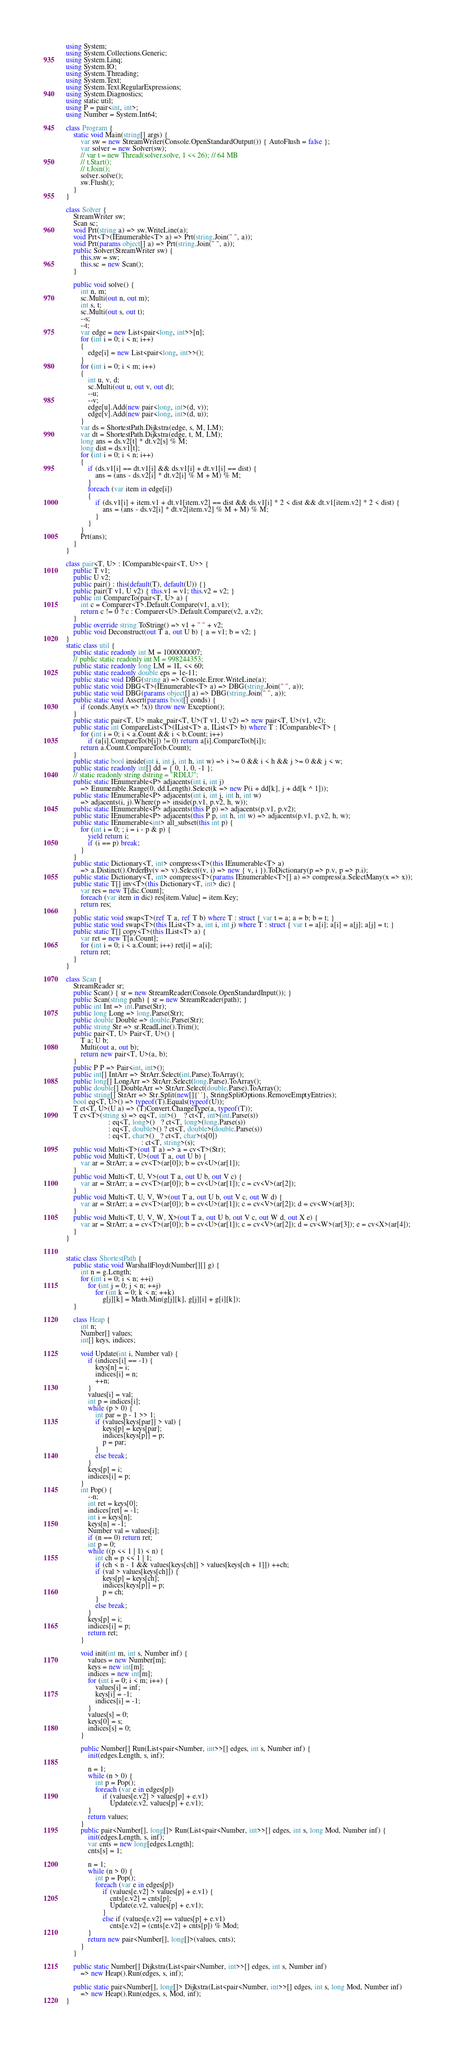<code> <loc_0><loc_0><loc_500><loc_500><_C#_>using System;
using System.Collections.Generic;
using System.Linq;
using System.IO;
using System.Threading;
using System.Text;
using System.Text.RegularExpressions;
using System.Diagnostics;
using static util;
using P = pair<int, int>;
using Number = System.Int64;

class Program {
    static void Main(string[] args) {
        var sw = new StreamWriter(Console.OpenStandardOutput()) { AutoFlush = false };
        var solver = new Solver(sw);
        // var t = new Thread(solver.solve, 1 << 26); // 64 MB
        // t.Start();
        // t.Join();
        solver.solve();
        sw.Flush();
    }
}

class Solver {
    StreamWriter sw;
    Scan sc;
    void Prt(string a) => sw.WriteLine(a);
    void Prt<T>(IEnumerable<T> a) => Prt(string.Join(" ", a));
    void Prt(params object[] a) => Prt(string.Join(" ", a));
    public Solver(StreamWriter sw) {
        this.sw = sw;
        this.sc = new Scan();
    }

    public void solve() {
        int n, m;
        sc.Multi(out n, out m);
        int s, t;
        sc.Multi(out s, out t);
        --s;
        --t;
        var edge = new List<pair<long, int>>[n];
        for (int i = 0; i < n; i++)
        {
            edge[i] = new List<pair<long, int>>();
        }
        for (int i = 0; i < m; i++)
        {
            int u, v, d;
            sc.Multi(out u, out v, out d);
            --u;
            --v;
            edge[u].Add(new pair<long, int>(d, v));
            edge[v].Add(new pair<long, int>(d, u));
        }
        var ds = ShortestPath.Dijkstra(edge, s, M, LM);
        var dt = ShortestPath.Dijkstra(edge, t, M, LM);
        long ans = ds.v2[t] * dt.v2[s] % M;
        long dist = ds.v1[t];
        for (int i = 0; i < n; i++)
        {
            if (ds.v1[i] == dt.v1[i] && ds.v1[i] + dt.v1[i] == dist) {
                ans = (ans - ds.v2[i] * dt.v2[i] % M + M) % M;
            }
            foreach (var item in edge[i])
            {
                if (ds.v1[i] + item.v1 + dt.v1[item.v2] == dist && ds.v1[i] * 2 < dist && dt.v1[item.v2] * 2 < dist) {
                    ans = (ans - ds.v2[i] * dt.v2[item.v2] % M + M) % M;
                }
            }
        }
        Prt(ans);
    }
}

class pair<T, U> : IComparable<pair<T, U>> {
    public T v1;
    public U v2;
    public pair() : this(default(T), default(U)) {}
    public pair(T v1, U v2) { this.v1 = v1; this.v2 = v2; }
    public int CompareTo(pair<T, U> a) {
        int c = Comparer<T>.Default.Compare(v1, a.v1);
        return c != 0 ? c : Comparer<U>.Default.Compare(v2, a.v2);
    }
    public override string ToString() => v1 + " " + v2;
    public void Deconstruct(out T a, out U b) { a = v1; b = v2; }
}
static class util {
    public static readonly int M = 1000000007;
    // public static readonly int M = 998244353;
    public static readonly long LM = 1L << 60;
    public static readonly double eps = 1e-11;
    public static void DBG(string a) => Console.Error.WriteLine(a);
    public static void DBG<T>(IEnumerable<T> a) => DBG(string.Join(" ", a));
    public static void DBG(params object[] a) => DBG(string.Join(" ", a));
    public static void Assert(params bool[] conds) {
        if (conds.Any(x => !x)) throw new Exception();
    }
    public static pair<T, U> make_pair<T, U>(T v1, U v2) => new pair<T, U>(v1, v2);
    public static int CompareList<T>(IList<T> a, IList<T> b) where T : IComparable<T> {
        for (int i = 0; i < a.Count && i < b.Count; i++)
            if (a[i].CompareTo(b[i]) != 0) return a[i].CompareTo(b[i]);
        return a.Count.CompareTo(b.Count);
    }
    public static bool inside(int i, int j, int h, int w) => i >= 0 && i < h && j >= 0 && j < w;
    public static readonly int[] dd = { 0, 1, 0, -1 };
    // static readonly string dstring = "RDLU";
    public static IEnumerable<P> adjacents(int i, int j)
        => Enumerable.Range(0, dd.Length).Select(k => new P(i + dd[k], j + dd[k ^ 1]));
    public static IEnumerable<P> adjacents(int i, int j, int h, int w)
        => adjacents(i, j).Where(p => inside(p.v1, p.v2, h, w));
    public static IEnumerable<P> adjacents(this P p) => adjacents(p.v1, p.v2);
    public static IEnumerable<P> adjacents(this P p, int h, int w) => adjacents(p.v1, p.v2, h, w);
    public static IEnumerable<int> all_subset(this int p) {
        for (int i = 0; ; i = i - p & p) {
            yield return i;
            if (i == p) break;
        }
    }
    public static Dictionary<T, int> compress<T>(this IEnumerable<T> a)
        => a.Distinct().OrderBy(v => v).Select((v, i) => new { v, i }).ToDictionary(p => p.v, p => p.i);
    public static Dictionary<T, int> compress<T>(params IEnumerable<T>[] a) => compress(a.SelectMany(x => x));
    public static T[] inv<T>(this Dictionary<T, int> dic) {
        var res = new T[dic.Count];
        foreach (var item in dic) res[item.Value] = item.Key;
        return res;
    }
    public static void swap<T>(ref T a, ref T b) where T : struct { var t = a; a = b; b = t; }
    public static void swap<T>(this IList<T> a, int i, int j) where T : struct { var t = a[i]; a[i] = a[j]; a[j] = t; }
    public static T[] copy<T>(this IList<T> a) {
        var ret = new T[a.Count];
        for (int i = 0; i < a.Count; i++) ret[i] = a[i];
        return ret;
    }
}

class Scan {
    StreamReader sr;
    public Scan() { sr = new StreamReader(Console.OpenStandardInput()); }
    public Scan(string path) { sr = new StreamReader(path); }
    public int Int => int.Parse(Str);
    public long Long => long.Parse(Str);
    public double Double => double.Parse(Str);
    public string Str => sr.ReadLine().Trim();
    public pair<T, U> Pair<T, U>() {
        T a; U b;
        Multi(out a, out b);
        return new pair<T, U>(a, b);
    }
    public P P => Pair<int, int>();
    public int[] IntArr => StrArr.Select(int.Parse).ToArray();
    public long[] LongArr => StrArr.Select(long.Parse).ToArray();
    public double[] DoubleArr => StrArr.Select(double.Parse).ToArray();
    public string[] StrArr => Str.Split(new[]{' '}, StringSplitOptions.RemoveEmptyEntries);
    bool eq<T, U>() => typeof(T).Equals(typeof(U));
    T ct<T, U>(U a) => (T)Convert.ChangeType(a, typeof(T));
    T cv<T>(string s) => eq<T, int>()    ? ct<T, int>(int.Parse(s))
                       : eq<T, long>()   ? ct<T, long>(long.Parse(s))
                       : eq<T, double>() ? ct<T, double>(double.Parse(s))
                       : eq<T, char>()   ? ct<T, char>(s[0])
                                         : ct<T, string>(s);
    public void Multi<T>(out T a) => a = cv<T>(Str);
    public void Multi<T, U>(out T a, out U b) {
        var ar = StrArr; a = cv<T>(ar[0]); b = cv<U>(ar[1]);
    }
    public void Multi<T, U, V>(out T a, out U b, out V c) {
        var ar = StrArr; a = cv<T>(ar[0]); b = cv<U>(ar[1]); c = cv<V>(ar[2]);
    }
    public void Multi<T, U, V, W>(out T a, out U b, out V c, out W d) {
        var ar = StrArr; a = cv<T>(ar[0]); b = cv<U>(ar[1]); c = cv<V>(ar[2]); d = cv<W>(ar[3]);
    }
    public void Multi<T, U, V, W, X>(out T a, out U b, out V c, out W d, out X e) {
        var ar = StrArr; a = cv<T>(ar[0]); b = cv<U>(ar[1]); c = cv<V>(ar[2]); d = cv<W>(ar[3]); e = cv<X>(ar[4]);
    }
}


static class ShortestPath {
    public static void WarshallFloyd(Number[][] g) {
        int n = g.Length;
        for (int i = 0; i < n; ++i)
            for (int j = 0; j < n; ++j)
                for (int k = 0; k < n; ++k)
                    g[j][k] = Math.Min(g[j][k], g[j][i] + g[i][k]);
    }

    class Heap {
        int n;
        Number[] values;
        int[] keys, indices;

        void Update(int i, Number val) {
            if (indices[i] == -1) {
                keys[n] = i;
                indices[i] = n;
                ++n;
            }
            values[i] = val;
            int p = indices[i];
            while (p > 0) {
                int par = p - 1 >> 1;
                if (values[keys[par]] > val) {
                    keys[p] = keys[par];
                    indices[keys[p]] = p;
                    p = par;
                }
                else break;
            }
            keys[p] = i;
            indices[i] = p;
        }
        int Pop() {
            --n;
            int ret = keys[0];
            indices[ret] = -1;
            int i = keys[n];
            keys[n] = -1;
            Number val = values[i];
            if (n == 0) return ret;
            int p = 0;
            while ((p << 1 | 1) < n) {
                int ch = p << 1 | 1;
                if (ch < n - 1 && values[keys[ch]] > values[keys[ch + 1]]) ++ch;
                if (val > values[keys[ch]]) {
                    keys[p] = keys[ch];
                    indices[keys[p]] = p;
                    p = ch;
                }
                else break;
            }
            keys[p] = i;
            indices[i] = p;
            return ret;
        }

        void init(int m, int s, Number inf) {
            values = new Number[m];
            keys = new int[m];
            indices = new int[m];
            for (int i = 0; i < m; i++) {
                values[i] = inf;
                keys[i] = -1;
                indices[i] = -1;
            }
            values[s] = 0;
            keys[0] = s;
            indices[s] = 0;
        }

        public Number[] Run(List<pair<Number, int>>[] edges, int s, Number inf) {
            init(edges.Length, s, inf);

            n = 1;
            while (n > 0) {
                int p = Pop();
                foreach (var e in edges[p])
                    if (values[e.v2] > values[p] + e.v1)
                        Update(e.v2, values[p] + e.v1);
            }
            return values;
        }
        public pair<Number[], long[]> Run(List<pair<Number, int>>[] edges, int s, long Mod, Number inf) {
            init(edges.Length, s, inf);
            var cnts = new long[edges.Length];
            cnts[s] = 1;

            n = 1;
            while (n > 0) {
                int p = Pop();
                foreach (var e in edges[p])
                    if (values[e.v2] > values[p] + e.v1) {
                        cnts[e.v2] = cnts[p];
                        Update(e.v2, values[p] + e.v1);
                    }
                    else if (values[e.v2] == values[p] + e.v1)
                        cnts[e.v2] = (cnts[e.v2] + cnts[p]) % Mod;
            }
            return new pair<Number[], long[]>(values, cnts);
        }
    }

    public static Number[] Dijkstra(List<pair<Number, int>>[] edges, int s, Number inf)
        => new Heap().Run(edges, s, inf);

    public static pair<Number[], long[]> Dijkstra(List<pair<Number, int>>[] edges, int s, long Mod, Number inf)
        => new Heap().Run(edges, s, Mod, inf);
}
</code> 